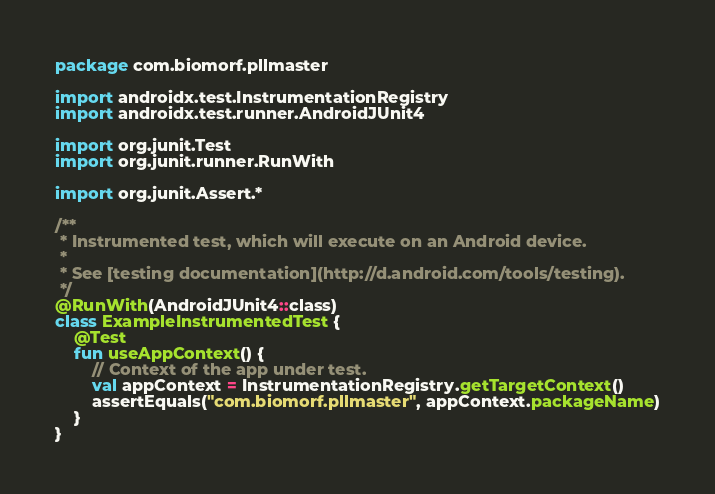<code> <loc_0><loc_0><loc_500><loc_500><_Kotlin_>package com.biomorf.pllmaster

import androidx.test.InstrumentationRegistry
import androidx.test.runner.AndroidJUnit4

import org.junit.Test
import org.junit.runner.RunWith

import org.junit.Assert.*

/**
 * Instrumented test, which will execute on an Android device.
 *
 * See [testing documentation](http://d.android.com/tools/testing).
 */
@RunWith(AndroidJUnit4::class)
class ExampleInstrumentedTest {
    @Test
    fun useAppContext() {
        // Context of the app under test.
        val appContext = InstrumentationRegistry.getTargetContext()
        assertEquals("com.biomorf.pllmaster", appContext.packageName)
    }
}
</code> 